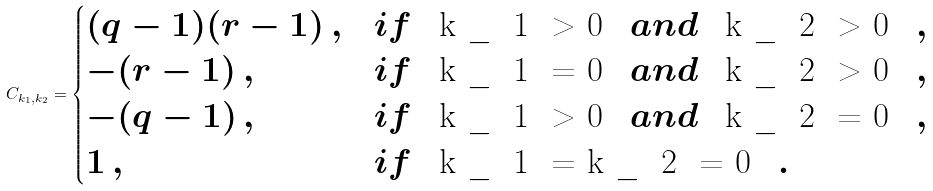Convert formula to latex. <formula><loc_0><loc_0><loc_500><loc_500>C _ { k _ { 1 } , k _ { 2 } } = \begin{cases} ( q - 1 ) ( r - 1 ) \, , & i f $ \, k _ { 1 } > 0 \, $ a n d $ \, k _ { 2 } > 0 \, $ , \\ - ( r - 1 ) \, , & i f $ \, k _ { 1 } = 0 \, $ a n d $ \, k _ { 2 } > 0 \, $ , \\ - ( q - 1 ) \, , & i f $ \, k _ { 1 } > 0 \, $ a n d $ \, k _ { 2 } = 0 \, $ , \\ 1 \, , & i f $ \, k _ { 1 } = k _ { 2 } = 0 \, $ . \end{cases}</formula> 